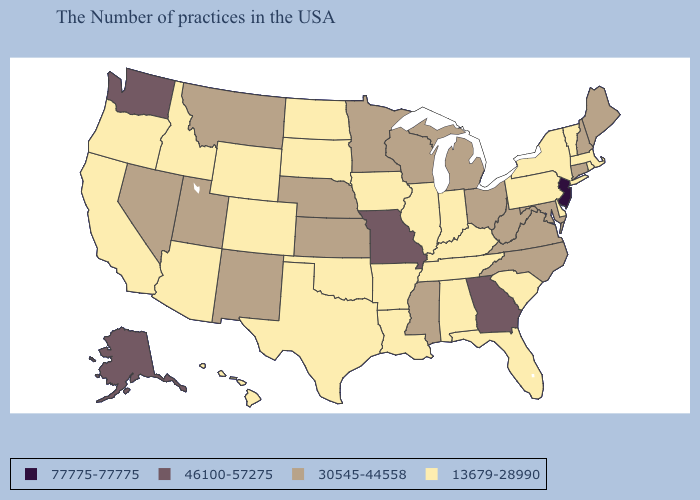Name the states that have a value in the range 77775-77775?
Write a very short answer. New Jersey. What is the value of Connecticut?
Short answer required. 30545-44558. Among the states that border Wisconsin , does Michigan have the lowest value?
Concise answer only. No. What is the highest value in the West ?
Give a very brief answer. 46100-57275. Name the states that have a value in the range 77775-77775?
Concise answer only. New Jersey. Does the map have missing data?
Write a very short answer. No. Among the states that border Vermont , which have the highest value?
Concise answer only. New Hampshire. Does West Virginia have the lowest value in the USA?
Give a very brief answer. No. What is the value of Indiana?
Keep it brief. 13679-28990. What is the highest value in states that border Michigan?
Quick response, please. 30545-44558. Name the states that have a value in the range 30545-44558?
Keep it brief. Maine, New Hampshire, Connecticut, Maryland, Virginia, North Carolina, West Virginia, Ohio, Michigan, Wisconsin, Mississippi, Minnesota, Kansas, Nebraska, New Mexico, Utah, Montana, Nevada. Which states have the highest value in the USA?
Write a very short answer. New Jersey. Among the states that border Minnesota , which have the lowest value?
Be succinct. Iowa, South Dakota, North Dakota. Which states have the highest value in the USA?
Concise answer only. New Jersey. 